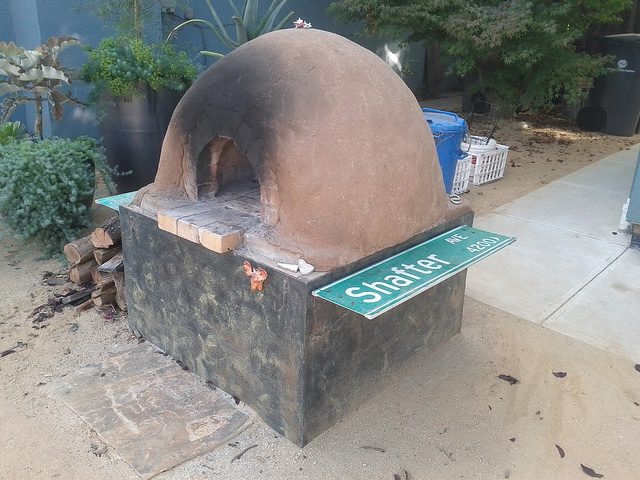Describe the objects in this image and their specific colors. I can see various objects in this image with different colors. 